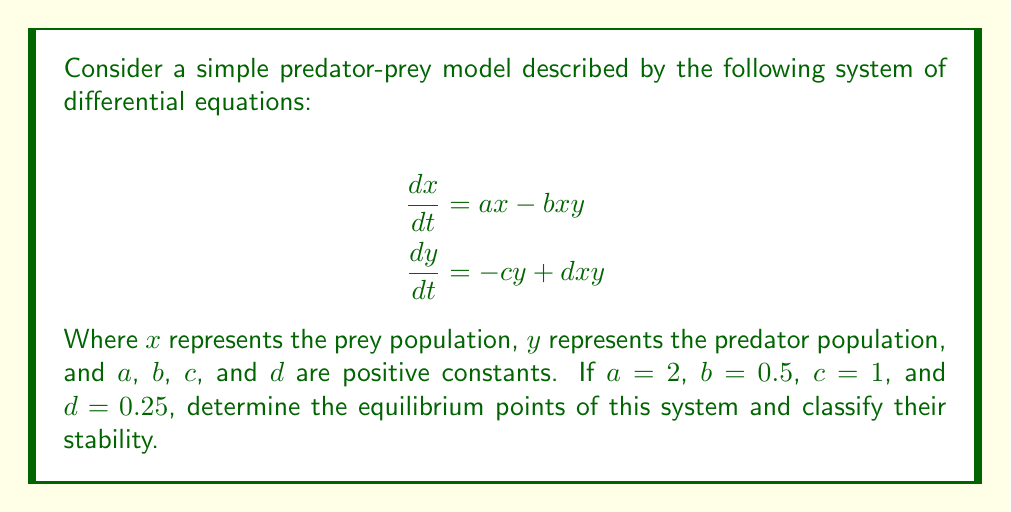Provide a solution to this math problem. Let's approach this step-by-step:

1) To find the equilibrium points, we set both equations equal to zero:

   $$\begin{aligned}
   0 &= ax - bxy \\
   0 &= -cy + dxy
   \end{aligned}$$

2) Substituting the given values:

   $$\begin{aligned}
   0 &= 2x - 0.5xy \\
   0 &= -y + 0.25xy
   \end{aligned}$$

3) From the second equation:
   $y = 0$ or $x = 4$

4) If $y = 0$, from the first equation:
   $2x = 0$, so $x = 0$

5) If $x = 4$, from the first equation:
   $8 = 2y$, so $y = 4$

6) Therefore, we have two equilibrium points: $(0, 0)$ and $(4, 4)$

7) To classify their stability, we need to find the Jacobian matrix:

   $$J = \begin{bmatrix}
   2 - 0.5y & -0.5x \\
   0.25y & -1 + 0.25x
   \end{bmatrix}$$

8) For $(0, 0)$:

   $$J_{(0,0)} = \begin{bmatrix}
   2 & 0 \\
   0 & -1
   \end{bmatrix}$$

   The eigenvalues are 2 and -1. Since one is positive and one is negative, $(0, 0)$ is a saddle point.

9) For $(4, 4)$:

   $$J_{(4,4)} = \begin{bmatrix}
   0 & -2 \\
   1 & 0
   \end{bmatrix}$$

   The eigenvalues are $\pm i\sqrt{2}$. Since they are purely imaginary, $(4, 4)$ is a center.

Therefore, $(0, 0)$ is an unstable equilibrium (saddle point), and $(4, 4)$ is a neutrally stable equilibrium (center).
Answer: Equilibrium points: $(0, 0)$ (saddle point) and $(4, 4)$ (center) 